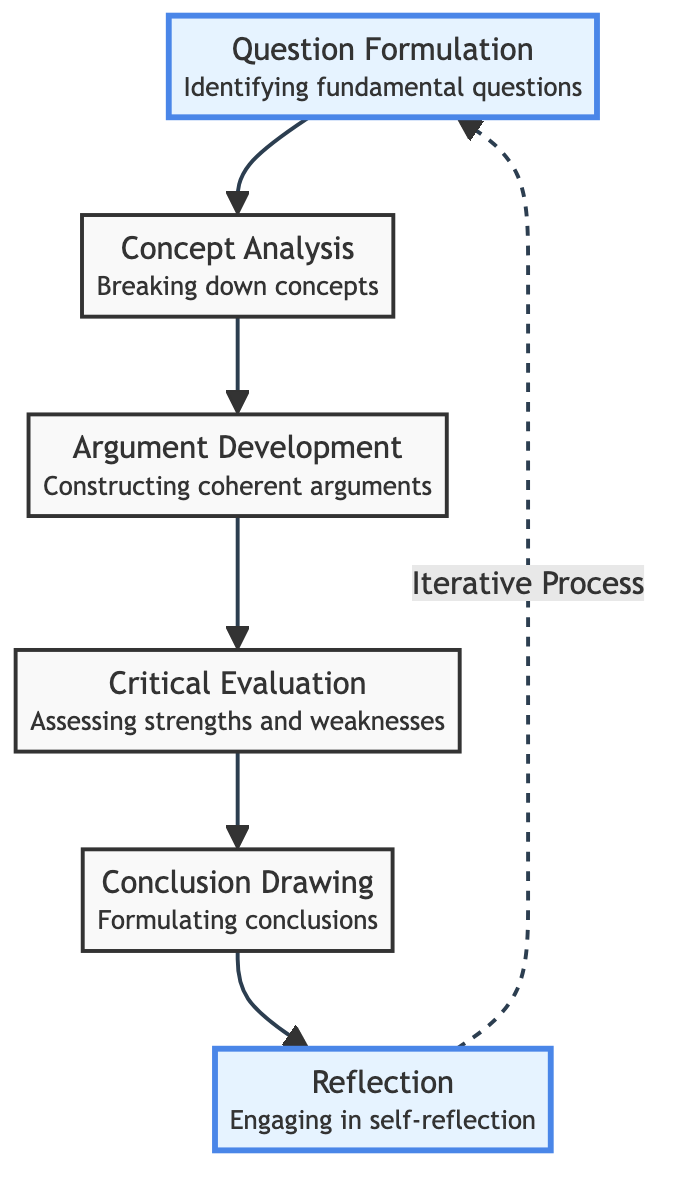What is the first step in the philosophical inquiry process according to the diagram? The diagram starts with "Question Formulation," indicating it is the first step in the process.
Answer: Question Formulation How many main stages are outlined in the diagram? The diagram shows a total of six stages, starting from Question Formulation to Reflection.
Answer: Six What follows after Concept Analysis in the flow? "Argument Development" follows directly after "Concept Analysis," indicating the next stage in the inquiry process.
Answer: Argument Development Which stage emphasizes self-reflection? The "Reflection" stage emphasizes self-reflection, as described in the flow chart.
Answer: Reflection What type of feedback loop is indicated in the diagram? The dashed line indicates an iterative process, showing that one can return to "Question Formulation" after "Reflection."
Answer: Iterative Process What is the last stage of the philosophical inquiry process? "Conclusion Drawing" is the last stage before the process moves to reflection.
Answer: Conclusion Drawing Which stages are connected through a solid line link? The stages connected by solid lines are Question Formulation, Concept Analysis, Argument Development, Critical Evaluation, and Conclusion Drawing.
Answer: Five stages What type of approach does the Critical Evaluation stage use? The Critical Evaluation stage uses a "dialectical" approach as derived from Garver’s teachings.
Answer: Dialectical approach 